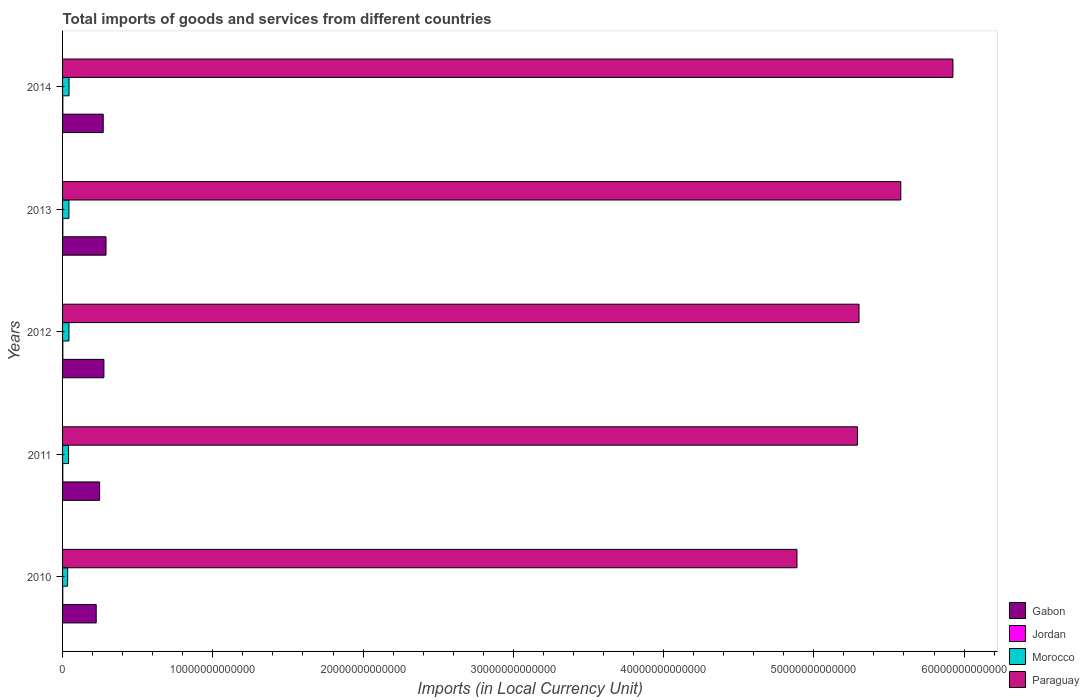How many different coloured bars are there?
Provide a short and direct response. 4. How many groups of bars are there?
Provide a short and direct response. 5. Are the number of bars on each tick of the Y-axis equal?
Offer a terse response. Yes. How many bars are there on the 4th tick from the top?
Keep it short and to the point. 4. In how many cases, is the number of bars for a given year not equal to the number of legend labels?
Offer a terse response. 0. What is the Amount of goods and services imports in Gabon in 2013?
Keep it short and to the point. 2.89e+12. Across all years, what is the maximum Amount of goods and services imports in Gabon?
Offer a very short reply. 2.89e+12. Across all years, what is the minimum Amount of goods and services imports in Jordan?
Your answer should be compact. 1.30e+1. In which year was the Amount of goods and services imports in Paraguay minimum?
Your response must be concise. 2010. What is the total Amount of goods and services imports in Jordan in the graph?
Your answer should be compact. 7.92e+1. What is the difference between the Amount of goods and services imports in Jordan in 2012 and that in 2014?
Keep it short and to the point. -1.29e+09. What is the difference between the Amount of goods and services imports in Paraguay in 2010 and the Amount of goods and services imports in Gabon in 2011?
Offer a terse response. 4.64e+13. What is the average Amount of goods and services imports in Paraguay per year?
Make the answer very short. 5.40e+13. In the year 2012, what is the difference between the Amount of goods and services imports in Morocco and Amount of goods and services imports in Jordan?
Provide a succinct answer. 4.09e+11. In how many years, is the Amount of goods and services imports in Gabon greater than 38000000000000 LCU?
Provide a short and direct response. 0. What is the ratio of the Amount of goods and services imports in Morocco in 2010 to that in 2013?
Offer a terse response. 0.8. What is the difference between the highest and the second highest Amount of goods and services imports in Jordan?
Provide a short and direct response. 4.42e+08. What is the difference between the highest and the lowest Amount of goods and services imports in Paraguay?
Make the answer very short. 1.04e+13. Is the sum of the Amount of goods and services imports in Paraguay in 2011 and 2013 greater than the maximum Amount of goods and services imports in Jordan across all years?
Offer a terse response. Yes. Is it the case that in every year, the sum of the Amount of goods and services imports in Morocco and Amount of goods and services imports in Gabon is greater than the sum of Amount of goods and services imports in Jordan and Amount of goods and services imports in Paraguay?
Keep it short and to the point. Yes. What does the 4th bar from the top in 2010 represents?
Offer a very short reply. Gabon. What does the 4th bar from the bottom in 2012 represents?
Provide a short and direct response. Paraguay. How many bars are there?
Your answer should be very brief. 20. Are all the bars in the graph horizontal?
Your response must be concise. Yes. How many years are there in the graph?
Provide a succinct answer. 5. What is the difference between two consecutive major ticks on the X-axis?
Your answer should be very brief. 1.00e+13. Are the values on the major ticks of X-axis written in scientific E-notation?
Make the answer very short. No. Does the graph contain grids?
Your answer should be compact. No. Where does the legend appear in the graph?
Offer a terse response. Bottom right. How many legend labels are there?
Provide a short and direct response. 4. What is the title of the graph?
Your response must be concise. Total imports of goods and services from different countries. Does "Hungary" appear as one of the legend labels in the graph?
Provide a succinct answer. No. What is the label or title of the X-axis?
Offer a very short reply. Imports (in Local Currency Unit). What is the label or title of the Y-axis?
Your answer should be compact. Years. What is the Imports (in Local Currency Unit) of Gabon in 2010?
Your response must be concise. 2.24e+12. What is the Imports (in Local Currency Unit) in Jordan in 2010?
Your answer should be very brief. 1.30e+1. What is the Imports (in Local Currency Unit) in Morocco in 2010?
Your response must be concise. 3.38e+11. What is the Imports (in Local Currency Unit) in Paraguay in 2010?
Your answer should be compact. 4.89e+13. What is the Imports (in Local Currency Unit) in Gabon in 2011?
Give a very brief answer. 2.47e+12. What is the Imports (in Local Currency Unit) of Jordan in 2011?
Your response must be concise. 1.51e+1. What is the Imports (in Local Currency Unit) of Morocco in 2011?
Provide a succinct answer. 4.00e+11. What is the Imports (in Local Currency Unit) in Paraguay in 2011?
Ensure brevity in your answer.  5.29e+13. What is the Imports (in Local Currency Unit) of Gabon in 2012?
Offer a terse response. 2.75e+12. What is the Imports (in Local Currency Unit) of Jordan in 2012?
Offer a terse response. 1.63e+1. What is the Imports (in Local Currency Unit) in Morocco in 2012?
Make the answer very short. 4.26e+11. What is the Imports (in Local Currency Unit) in Paraguay in 2012?
Provide a succinct answer. 5.30e+13. What is the Imports (in Local Currency Unit) in Gabon in 2013?
Offer a terse response. 2.89e+12. What is the Imports (in Local Currency Unit) of Jordan in 2013?
Your answer should be very brief. 1.72e+1. What is the Imports (in Local Currency Unit) in Morocco in 2013?
Offer a terse response. 4.24e+11. What is the Imports (in Local Currency Unit) in Paraguay in 2013?
Your response must be concise. 5.58e+13. What is the Imports (in Local Currency Unit) of Gabon in 2014?
Keep it short and to the point. 2.71e+12. What is the Imports (in Local Currency Unit) of Jordan in 2014?
Your answer should be compact. 1.76e+1. What is the Imports (in Local Currency Unit) in Morocco in 2014?
Offer a very short reply. 4.31e+11. What is the Imports (in Local Currency Unit) in Paraguay in 2014?
Your response must be concise. 5.93e+13. Across all years, what is the maximum Imports (in Local Currency Unit) of Gabon?
Your answer should be compact. 2.89e+12. Across all years, what is the maximum Imports (in Local Currency Unit) in Jordan?
Make the answer very short. 1.76e+1. Across all years, what is the maximum Imports (in Local Currency Unit) of Morocco?
Your answer should be very brief. 4.31e+11. Across all years, what is the maximum Imports (in Local Currency Unit) in Paraguay?
Offer a terse response. 5.93e+13. Across all years, what is the minimum Imports (in Local Currency Unit) in Gabon?
Make the answer very short. 2.24e+12. Across all years, what is the minimum Imports (in Local Currency Unit) in Jordan?
Give a very brief answer. 1.30e+1. Across all years, what is the minimum Imports (in Local Currency Unit) of Morocco?
Your answer should be compact. 3.38e+11. Across all years, what is the minimum Imports (in Local Currency Unit) in Paraguay?
Offer a terse response. 4.89e+13. What is the total Imports (in Local Currency Unit) of Gabon in the graph?
Provide a succinct answer. 1.31e+13. What is the total Imports (in Local Currency Unit) of Jordan in the graph?
Make the answer very short. 7.92e+1. What is the total Imports (in Local Currency Unit) of Morocco in the graph?
Your answer should be compact. 2.02e+12. What is the total Imports (in Local Currency Unit) of Paraguay in the graph?
Provide a short and direct response. 2.70e+14. What is the difference between the Imports (in Local Currency Unit) of Gabon in 2010 and that in 2011?
Provide a short and direct response. -2.28e+11. What is the difference between the Imports (in Local Currency Unit) of Jordan in 2010 and that in 2011?
Your answer should be compact. -2.17e+09. What is the difference between the Imports (in Local Currency Unit) in Morocco in 2010 and that in 2011?
Offer a terse response. -6.21e+1. What is the difference between the Imports (in Local Currency Unit) of Paraguay in 2010 and that in 2011?
Give a very brief answer. -4.03e+12. What is the difference between the Imports (in Local Currency Unit) in Gabon in 2010 and that in 2012?
Provide a short and direct response. -5.12e+11. What is the difference between the Imports (in Local Currency Unit) of Jordan in 2010 and that in 2012?
Your response must be concise. -3.36e+09. What is the difference between the Imports (in Local Currency Unit) of Morocco in 2010 and that in 2012?
Make the answer very short. -8.81e+1. What is the difference between the Imports (in Local Currency Unit) of Paraguay in 2010 and that in 2012?
Your answer should be very brief. -4.13e+12. What is the difference between the Imports (in Local Currency Unit) of Gabon in 2010 and that in 2013?
Ensure brevity in your answer.  -6.52e+11. What is the difference between the Imports (in Local Currency Unit) of Jordan in 2010 and that in 2013?
Provide a succinct answer. -4.21e+09. What is the difference between the Imports (in Local Currency Unit) of Morocco in 2010 and that in 2013?
Keep it short and to the point. -8.67e+1. What is the difference between the Imports (in Local Currency Unit) in Paraguay in 2010 and that in 2013?
Offer a very short reply. -6.91e+12. What is the difference between the Imports (in Local Currency Unit) of Gabon in 2010 and that in 2014?
Your answer should be very brief. -4.67e+11. What is the difference between the Imports (in Local Currency Unit) in Jordan in 2010 and that in 2014?
Offer a very short reply. -4.65e+09. What is the difference between the Imports (in Local Currency Unit) of Morocco in 2010 and that in 2014?
Give a very brief answer. -9.36e+1. What is the difference between the Imports (in Local Currency Unit) of Paraguay in 2010 and that in 2014?
Offer a very short reply. -1.04e+13. What is the difference between the Imports (in Local Currency Unit) in Gabon in 2011 and that in 2012?
Provide a short and direct response. -2.84e+11. What is the difference between the Imports (in Local Currency Unit) of Jordan in 2011 and that in 2012?
Offer a very short reply. -1.19e+09. What is the difference between the Imports (in Local Currency Unit) in Morocco in 2011 and that in 2012?
Your answer should be very brief. -2.60e+1. What is the difference between the Imports (in Local Currency Unit) of Paraguay in 2011 and that in 2012?
Provide a succinct answer. -1.05e+11. What is the difference between the Imports (in Local Currency Unit) of Gabon in 2011 and that in 2013?
Your answer should be compact. -4.24e+11. What is the difference between the Imports (in Local Currency Unit) of Jordan in 2011 and that in 2013?
Offer a terse response. -2.04e+09. What is the difference between the Imports (in Local Currency Unit) of Morocco in 2011 and that in 2013?
Your response must be concise. -2.46e+1. What is the difference between the Imports (in Local Currency Unit) of Paraguay in 2011 and that in 2013?
Your answer should be very brief. -2.89e+12. What is the difference between the Imports (in Local Currency Unit) in Gabon in 2011 and that in 2014?
Your response must be concise. -2.39e+11. What is the difference between the Imports (in Local Currency Unit) in Jordan in 2011 and that in 2014?
Offer a very short reply. -2.48e+09. What is the difference between the Imports (in Local Currency Unit) in Morocco in 2011 and that in 2014?
Make the answer very short. -3.15e+1. What is the difference between the Imports (in Local Currency Unit) of Paraguay in 2011 and that in 2014?
Offer a very short reply. -6.36e+12. What is the difference between the Imports (in Local Currency Unit) of Gabon in 2012 and that in 2013?
Make the answer very short. -1.40e+11. What is the difference between the Imports (in Local Currency Unit) of Jordan in 2012 and that in 2013?
Keep it short and to the point. -8.50e+08. What is the difference between the Imports (in Local Currency Unit) of Morocco in 2012 and that in 2013?
Provide a succinct answer. 1.39e+09. What is the difference between the Imports (in Local Currency Unit) in Paraguay in 2012 and that in 2013?
Give a very brief answer. -2.78e+12. What is the difference between the Imports (in Local Currency Unit) of Gabon in 2012 and that in 2014?
Make the answer very short. 4.55e+1. What is the difference between the Imports (in Local Currency Unit) in Jordan in 2012 and that in 2014?
Your answer should be compact. -1.29e+09. What is the difference between the Imports (in Local Currency Unit) of Morocco in 2012 and that in 2014?
Make the answer very short. -5.54e+09. What is the difference between the Imports (in Local Currency Unit) of Paraguay in 2012 and that in 2014?
Ensure brevity in your answer.  -6.25e+12. What is the difference between the Imports (in Local Currency Unit) in Gabon in 2013 and that in 2014?
Offer a very short reply. 1.85e+11. What is the difference between the Imports (in Local Currency Unit) in Jordan in 2013 and that in 2014?
Your answer should be very brief. -4.42e+08. What is the difference between the Imports (in Local Currency Unit) of Morocco in 2013 and that in 2014?
Provide a succinct answer. -6.93e+09. What is the difference between the Imports (in Local Currency Unit) of Paraguay in 2013 and that in 2014?
Ensure brevity in your answer.  -3.47e+12. What is the difference between the Imports (in Local Currency Unit) of Gabon in 2010 and the Imports (in Local Currency Unit) of Jordan in 2011?
Keep it short and to the point. 2.22e+12. What is the difference between the Imports (in Local Currency Unit) in Gabon in 2010 and the Imports (in Local Currency Unit) in Morocco in 2011?
Provide a succinct answer. 1.84e+12. What is the difference between the Imports (in Local Currency Unit) of Gabon in 2010 and the Imports (in Local Currency Unit) of Paraguay in 2011?
Ensure brevity in your answer.  -5.07e+13. What is the difference between the Imports (in Local Currency Unit) in Jordan in 2010 and the Imports (in Local Currency Unit) in Morocco in 2011?
Provide a succinct answer. -3.87e+11. What is the difference between the Imports (in Local Currency Unit) of Jordan in 2010 and the Imports (in Local Currency Unit) of Paraguay in 2011?
Offer a very short reply. -5.29e+13. What is the difference between the Imports (in Local Currency Unit) in Morocco in 2010 and the Imports (in Local Currency Unit) in Paraguay in 2011?
Give a very brief answer. -5.26e+13. What is the difference between the Imports (in Local Currency Unit) of Gabon in 2010 and the Imports (in Local Currency Unit) of Jordan in 2012?
Offer a terse response. 2.22e+12. What is the difference between the Imports (in Local Currency Unit) in Gabon in 2010 and the Imports (in Local Currency Unit) in Morocco in 2012?
Your answer should be compact. 1.81e+12. What is the difference between the Imports (in Local Currency Unit) of Gabon in 2010 and the Imports (in Local Currency Unit) of Paraguay in 2012?
Your response must be concise. -5.08e+13. What is the difference between the Imports (in Local Currency Unit) in Jordan in 2010 and the Imports (in Local Currency Unit) in Morocco in 2012?
Make the answer very short. -4.13e+11. What is the difference between the Imports (in Local Currency Unit) of Jordan in 2010 and the Imports (in Local Currency Unit) of Paraguay in 2012?
Your answer should be very brief. -5.30e+13. What is the difference between the Imports (in Local Currency Unit) in Morocco in 2010 and the Imports (in Local Currency Unit) in Paraguay in 2012?
Provide a succinct answer. -5.27e+13. What is the difference between the Imports (in Local Currency Unit) in Gabon in 2010 and the Imports (in Local Currency Unit) in Jordan in 2013?
Your response must be concise. 2.22e+12. What is the difference between the Imports (in Local Currency Unit) of Gabon in 2010 and the Imports (in Local Currency Unit) of Morocco in 2013?
Your response must be concise. 1.82e+12. What is the difference between the Imports (in Local Currency Unit) of Gabon in 2010 and the Imports (in Local Currency Unit) of Paraguay in 2013?
Offer a very short reply. -5.35e+13. What is the difference between the Imports (in Local Currency Unit) in Jordan in 2010 and the Imports (in Local Currency Unit) in Morocco in 2013?
Provide a short and direct response. -4.11e+11. What is the difference between the Imports (in Local Currency Unit) in Jordan in 2010 and the Imports (in Local Currency Unit) in Paraguay in 2013?
Offer a terse response. -5.58e+13. What is the difference between the Imports (in Local Currency Unit) of Morocco in 2010 and the Imports (in Local Currency Unit) of Paraguay in 2013?
Your answer should be very brief. -5.55e+13. What is the difference between the Imports (in Local Currency Unit) of Gabon in 2010 and the Imports (in Local Currency Unit) of Jordan in 2014?
Ensure brevity in your answer.  2.22e+12. What is the difference between the Imports (in Local Currency Unit) in Gabon in 2010 and the Imports (in Local Currency Unit) in Morocco in 2014?
Your answer should be compact. 1.81e+12. What is the difference between the Imports (in Local Currency Unit) in Gabon in 2010 and the Imports (in Local Currency Unit) in Paraguay in 2014?
Make the answer very short. -5.70e+13. What is the difference between the Imports (in Local Currency Unit) of Jordan in 2010 and the Imports (in Local Currency Unit) of Morocco in 2014?
Ensure brevity in your answer.  -4.18e+11. What is the difference between the Imports (in Local Currency Unit) in Jordan in 2010 and the Imports (in Local Currency Unit) in Paraguay in 2014?
Offer a very short reply. -5.92e+13. What is the difference between the Imports (in Local Currency Unit) in Morocco in 2010 and the Imports (in Local Currency Unit) in Paraguay in 2014?
Give a very brief answer. -5.89e+13. What is the difference between the Imports (in Local Currency Unit) of Gabon in 2011 and the Imports (in Local Currency Unit) of Jordan in 2012?
Provide a succinct answer. 2.45e+12. What is the difference between the Imports (in Local Currency Unit) in Gabon in 2011 and the Imports (in Local Currency Unit) in Morocco in 2012?
Your answer should be compact. 2.04e+12. What is the difference between the Imports (in Local Currency Unit) in Gabon in 2011 and the Imports (in Local Currency Unit) in Paraguay in 2012?
Keep it short and to the point. -5.05e+13. What is the difference between the Imports (in Local Currency Unit) in Jordan in 2011 and the Imports (in Local Currency Unit) in Morocco in 2012?
Keep it short and to the point. -4.10e+11. What is the difference between the Imports (in Local Currency Unit) in Jordan in 2011 and the Imports (in Local Currency Unit) in Paraguay in 2012?
Your answer should be very brief. -5.30e+13. What is the difference between the Imports (in Local Currency Unit) of Morocco in 2011 and the Imports (in Local Currency Unit) of Paraguay in 2012?
Offer a very short reply. -5.26e+13. What is the difference between the Imports (in Local Currency Unit) in Gabon in 2011 and the Imports (in Local Currency Unit) in Jordan in 2013?
Offer a terse response. 2.45e+12. What is the difference between the Imports (in Local Currency Unit) of Gabon in 2011 and the Imports (in Local Currency Unit) of Morocco in 2013?
Your answer should be compact. 2.04e+12. What is the difference between the Imports (in Local Currency Unit) of Gabon in 2011 and the Imports (in Local Currency Unit) of Paraguay in 2013?
Offer a terse response. -5.33e+13. What is the difference between the Imports (in Local Currency Unit) of Jordan in 2011 and the Imports (in Local Currency Unit) of Morocco in 2013?
Your answer should be very brief. -4.09e+11. What is the difference between the Imports (in Local Currency Unit) of Jordan in 2011 and the Imports (in Local Currency Unit) of Paraguay in 2013?
Your answer should be compact. -5.58e+13. What is the difference between the Imports (in Local Currency Unit) of Morocco in 2011 and the Imports (in Local Currency Unit) of Paraguay in 2013?
Provide a short and direct response. -5.54e+13. What is the difference between the Imports (in Local Currency Unit) of Gabon in 2011 and the Imports (in Local Currency Unit) of Jordan in 2014?
Give a very brief answer. 2.45e+12. What is the difference between the Imports (in Local Currency Unit) in Gabon in 2011 and the Imports (in Local Currency Unit) in Morocco in 2014?
Provide a succinct answer. 2.04e+12. What is the difference between the Imports (in Local Currency Unit) in Gabon in 2011 and the Imports (in Local Currency Unit) in Paraguay in 2014?
Ensure brevity in your answer.  -5.68e+13. What is the difference between the Imports (in Local Currency Unit) in Jordan in 2011 and the Imports (in Local Currency Unit) in Morocco in 2014?
Provide a succinct answer. -4.16e+11. What is the difference between the Imports (in Local Currency Unit) in Jordan in 2011 and the Imports (in Local Currency Unit) in Paraguay in 2014?
Make the answer very short. -5.92e+13. What is the difference between the Imports (in Local Currency Unit) in Morocco in 2011 and the Imports (in Local Currency Unit) in Paraguay in 2014?
Give a very brief answer. -5.89e+13. What is the difference between the Imports (in Local Currency Unit) in Gabon in 2012 and the Imports (in Local Currency Unit) in Jordan in 2013?
Offer a terse response. 2.73e+12. What is the difference between the Imports (in Local Currency Unit) of Gabon in 2012 and the Imports (in Local Currency Unit) of Morocco in 2013?
Provide a short and direct response. 2.33e+12. What is the difference between the Imports (in Local Currency Unit) in Gabon in 2012 and the Imports (in Local Currency Unit) in Paraguay in 2013?
Your answer should be compact. -5.30e+13. What is the difference between the Imports (in Local Currency Unit) of Jordan in 2012 and the Imports (in Local Currency Unit) of Morocco in 2013?
Offer a terse response. -4.08e+11. What is the difference between the Imports (in Local Currency Unit) in Jordan in 2012 and the Imports (in Local Currency Unit) in Paraguay in 2013?
Ensure brevity in your answer.  -5.58e+13. What is the difference between the Imports (in Local Currency Unit) in Morocco in 2012 and the Imports (in Local Currency Unit) in Paraguay in 2013?
Give a very brief answer. -5.54e+13. What is the difference between the Imports (in Local Currency Unit) in Gabon in 2012 and the Imports (in Local Currency Unit) in Jordan in 2014?
Offer a terse response. 2.73e+12. What is the difference between the Imports (in Local Currency Unit) of Gabon in 2012 and the Imports (in Local Currency Unit) of Morocco in 2014?
Give a very brief answer. 2.32e+12. What is the difference between the Imports (in Local Currency Unit) in Gabon in 2012 and the Imports (in Local Currency Unit) in Paraguay in 2014?
Offer a terse response. -5.65e+13. What is the difference between the Imports (in Local Currency Unit) of Jordan in 2012 and the Imports (in Local Currency Unit) of Morocco in 2014?
Keep it short and to the point. -4.15e+11. What is the difference between the Imports (in Local Currency Unit) in Jordan in 2012 and the Imports (in Local Currency Unit) in Paraguay in 2014?
Offer a very short reply. -5.92e+13. What is the difference between the Imports (in Local Currency Unit) in Morocco in 2012 and the Imports (in Local Currency Unit) in Paraguay in 2014?
Provide a short and direct response. -5.88e+13. What is the difference between the Imports (in Local Currency Unit) in Gabon in 2013 and the Imports (in Local Currency Unit) in Jordan in 2014?
Offer a very short reply. 2.87e+12. What is the difference between the Imports (in Local Currency Unit) of Gabon in 2013 and the Imports (in Local Currency Unit) of Morocco in 2014?
Your answer should be compact. 2.46e+12. What is the difference between the Imports (in Local Currency Unit) in Gabon in 2013 and the Imports (in Local Currency Unit) in Paraguay in 2014?
Give a very brief answer. -5.64e+13. What is the difference between the Imports (in Local Currency Unit) of Jordan in 2013 and the Imports (in Local Currency Unit) of Morocco in 2014?
Ensure brevity in your answer.  -4.14e+11. What is the difference between the Imports (in Local Currency Unit) in Jordan in 2013 and the Imports (in Local Currency Unit) in Paraguay in 2014?
Your response must be concise. -5.92e+13. What is the difference between the Imports (in Local Currency Unit) in Morocco in 2013 and the Imports (in Local Currency Unit) in Paraguay in 2014?
Offer a very short reply. -5.88e+13. What is the average Imports (in Local Currency Unit) in Gabon per year?
Your answer should be compact. 2.61e+12. What is the average Imports (in Local Currency Unit) of Jordan per year?
Provide a succinct answer. 1.58e+1. What is the average Imports (in Local Currency Unit) of Morocco per year?
Ensure brevity in your answer.  4.04e+11. What is the average Imports (in Local Currency Unit) in Paraguay per year?
Your answer should be very brief. 5.40e+13. In the year 2010, what is the difference between the Imports (in Local Currency Unit) of Gabon and Imports (in Local Currency Unit) of Jordan?
Give a very brief answer. 2.23e+12. In the year 2010, what is the difference between the Imports (in Local Currency Unit) of Gabon and Imports (in Local Currency Unit) of Morocco?
Offer a terse response. 1.90e+12. In the year 2010, what is the difference between the Imports (in Local Currency Unit) in Gabon and Imports (in Local Currency Unit) in Paraguay?
Your answer should be very brief. -4.66e+13. In the year 2010, what is the difference between the Imports (in Local Currency Unit) of Jordan and Imports (in Local Currency Unit) of Morocco?
Your response must be concise. -3.25e+11. In the year 2010, what is the difference between the Imports (in Local Currency Unit) of Jordan and Imports (in Local Currency Unit) of Paraguay?
Keep it short and to the point. -4.89e+13. In the year 2010, what is the difference between the Imports (in Local Currency Unit) in Morocco and Imports (in Local Currency Unit) in Paraguay?
Offer a very short reply. -4.85e+13. In the year 2011, what is the difference between the Imports (in Local Currency Unit) in Gabon and Imports (in Local Currency Unit) in Jordan?
Your answer should be very brief. 2.45e+12. In the year 2011, what is the difference between the Imports (in Local Currency Unit) in Gabon and Imports (in Local Currency Unit) in Morocco?
Offer a terse response. 2.07e+12. In the year 2011, what is the difference between the Imports (in Local Currency Unit) of Gabon and Imports (in Local Currency Unit) of Paraguay?
Offer a very short reply. -5.04e+13. In the year 2011, what is the difference between the Imports (in Local Currency Unit) of Jordan and Imports (in Local Currency Unit) of Morocco?
Provide a short and direct response. -3.84e+11. In the year 2011, what is the difference between the Imports (in Local Currency Unit) of Jordan and Imports (in Local Currency Unit) of Paraguay?
Keep it short and to the point. -5.29e+13. In the year 2011, what is the difference between the Imports (in Local Currency Unit) in Morocco and Imports (in Local Currency Unit) in Paraguay?
Keep it short and to the point. -5.25e+13. In the year 2012, what is the difference between the Imports (in Local Currency Unit) in Gabon and Imports (in Local Currency Unit) in Jordan?
Offer a very short reply. 2.74e+12. In the year 2012, what is the difference between the Imports (in Local Currency Unit) in Gabon and Imports (in Local Currency Unit) in Morocco?
Provide a short and direct response. 2.33e+12. In the year 2012, what is the difference between the Imports (in Local Currency Unit) of Gabon and Imports (in Local Currency Unit) of Paraguay?
Keep it short and to the point. -5.03e+13. In the year 2012, what is the difference between the Imports (in Local Currency Unit) in Jordan and Imports (in Local Currency Unit) in Morocco?
Make the answer very short. -4.09e+11. In the year 2012, what is the difference between the Imports (in Local Currency Unit) of Jordan and Imports (in Local Currency Unit) of Paraguay?
Your answer should be compact. -5.30e+13. In the year 2012, what is the difference between the Imports (in Local Currency Unit) of Morocco and Imports (in Local Currency Unit) of Paraguay?
Ensure brevity in your answer.  -5.26e+13. In the year 2013, what is the difference between the Imports (in Local Currency Unit) of Gabon and Imports (in Local Currency Unit) of Jordan?
Offer a terse response. 2.87e+12. In the year 2013, what is the difference between the Imports (in Local Currency Unit) of Gabon and Imports (in Local Currency Unit) of Morocco?
Your answer should be compact. 2.47e+12. In the year 2013, what is the difference between the Imports (in Local Currency Unit) of Gabon and Imports (in Local Currency Unit) of Paraguay?
Give a very brief answer. -5.29e+13. In the year 2013, what is the difference between the Imports (in Local Currency Unit) of Jordan and Imports (in Local Currency Unit) of Morocco?
Keep it short and to the point. -4.07e+11. In the year 2013, what is the difference between the Imports (in Local Currency Unit) in Jordan and Imports (in Local Currency Unit) in Paraguay?
Ensure brevity in your answer.  -5.58e+13. In the year 2013, what is the difference between the Imports (in Local Currency Unit) of Morocco and Imports (in Local Currency Unit) of Paraguay?
Provide a short and direct response. -5.54e+13. In the year 2014, what is the difference between the Imports (in Local Currency Unit) in Gabon and Imports (in Local Currency Unit) in Jordan?
Your response must be concise. 2.69e+12. In the year 2014, what is the difference between the Imports (in Local Currency Unit) in Gabon and Imports (in Local Currency Unit) in Morocco?
Your response must be concise. 2.28e+12. In the year 2014, what is the difference between the Imports (in Local Currency Unit) in Gabon and Imports (in Local Currency Unit) in Paraguay?
Offer a very short reply. -5.66e+13. In the year 2014, what is the difference between the Imports (in Local Currency Unit) in Jordan and Imports (in Local Currency Unit) in Morocco?
Ensure brevity in your answer.  -4.14e+11. In the year 2014, what is the difference between the Imports (in Local Currency Unit) of Jordan and Imports (in Local Currency Unit) of Paraguay?
Your answer should be compact. -5.92e+13. In the year 2014, what is the difference between the Imports (in Local Currency Unit) of Morocco and Imports (in Local Currency Unit) of Paraguay?
Your response must be concise. -5.88e+13. What is the ratio of the Imports (in Local Currency Unit) of Gabon in 2010 to that in 2011?
Provide a succinct answer. 0.91. What is the ratio of the Imports (in Local Currency Unit) in Jordan in 2010 to that in 2011?
Offer a terse response. 0.86. What is the ratio of the Imports (in Local Currency Unit) in Morocco in 2010 to that in 2011?
Offer a terse response. 0.84. What is the ratio of the Imports (in Local Currency Unit) of Paraguay in 2010 to that in 2011?
Keep it short and to the point. 0.92. What is the ratio of the Imports (in Local Currency Unit) in Gabon in 2010 to that in 2012?
Provide a short and direct response. 0.81. What is the ratio of the Imports (in Local Currency Unit) in Jordan in 2010 to that in 2012?
Ensure brevity in your answer.  0.79. What is the ratio of the Imports (in Local Currency Unit) of Morocco in 2010 to that in 2012?
Your answer should be very brief. 0.79. What is the ratio of the Imports (in Local Currency Unit) in Paraguay in 2010 to that in 2012?
Give a very brief answer. 0.92. What is the ratio of the Imports (in Local Currency Unit) of Gabon in 2010 to that in 2013?
Ensure brevity in your answer.  0.77. What is the ratio of the Imports (in Local Currency Unit) of Jordan in 2010 to that in 2013?
Your answer should be very brief. 0.75. What is the ratio of the Imports (in Local Currency Unit) of Morocco in 2010 to that in 2013?
Ensure brevity in your answer.  0.8. What is the ratio of the Imports (in Local Currency Unit) in Paraguay in 2010 to that in 2013?
Provide a succinct answer. 0.88. What is the ratio of the Imports (in Local Currency Unit) of Gabon in 2010 to that in 2014?
Keep it short and to the point. 0.83. What is the ratio of the Imports (in Local Currency Unit) in Jordan in 2010 to that in 2014?
Make the answer very short. 0.74. What is the ratio of the Imports (in Local Currency Unit) of Morocco in 2010 to that in 2014?
Provide a short and direct response. 0.78. What is the ratio of the Imports (in Local Currency Unit) in Paraguay in 2010 to that in 2014?
Offer a terse response. 0.82. What is the ratio of the Imports (in Local Currency Unit) in Gabon in 2011 to that in 2012?
Offer a terse response. 0.9. What is the ratio of the Imports (in Local Currency Unit) of Jordan in 2011 to that in 2012?
Offer a terse response. 0.93. What is the ratio of the Imports (in Local Currency Unit) in Morocco in 2011 to that in 2012?
Provide a succinct answer. 0.94. What is the ratio of the Imports (in Local Currency Unit) of Gabon in 2011 to that in 2013?
Your answer should be very brief. 0.85. What is the ratio of the Imports (in Local Currency Unit) in Jordan in 2011 to that in 2013?
Give a very brief answer. 0.88. What is the ratio of the Imports (in Local Currency Unit) of Morocco in 2011 to that in 2013?
Keep it short and to the point. 0.94. What is the ratio of the Imports (in Local Currency Unit) in Paraguay in 2011 to that in 2013?
Offer a very short reply. 0.95. What is the ratio of the Imports (in Local Currency Unit) of Gabon in 2011 to that in 2014?
Make the answer very short. 0.91. What is the ratio of the Imports (in Local Currency Unit) of Jordan in 2011 to that in 2014?
Give a very brief answer. 0.86. What is the ratio of the Imports (in Local Currency Unit) of Morocco in 2011 to that in 2014?
Make the answer very short. 0.93. What is the ratio of the Imports (in Local Currency Unit) of Paraguay in 2011 to that in 2014?
Your answer should be very brief. 0.89. What is the ratio of the Imports (in Local Currency Unit) of Gabon in 2012 to that in 2013?
Provide a succinct answer. 0.95. What is the ratio of the Imports (in Local Currency Unit) of Jordan in 2012 to that in 2013?
Offer a very short reply. 0.95. What is the ratio of the Imports (in Local Currency Unit) of Paraguay in 2012 to that in 2013?
Make the answer very short. 0.95. What is the ratio of the Imports (in Local Currency Unit) of Gabon in 2012 to that in 2014?
Your answer should be very brief. 1.02. What is the ratio of the Imports (in Local Currency Unit) in Jordan in 2012 to that in 2014?
Offer a terse response. 0.93. What is the ratio of the Imports (in Local Currency Unit) in Morocco in 2012 to that in 2014?
Give a very brief answer. 0.99. What is the ratio of the Imports (in Local Currency Unit) of Paraguay in 2012 to that in 2014?
Ensure brevity in your answer.  0.89. What is the ratio of the Imports (in Local Currency Unit) in Gabon in 2013 to that in 2014?
Your response must be concise. 1.07. What is the ratio of the Imports (in Local Currency Unit) in Jordan in 2013 to that in 2014?
Provide a short and direct response. 0.97. What is the ratio of the Imports (in Local Currency Unit) in Morocco in 2013 to that in 2014?
Give a very brief answer. 0.98. What is the ratio of the Imports (in Local Currency Unit) of Paraguay in 2013 to that in 2014?
Make the answer very short. 0.94. What is the difference between the highest and the second highest Imports (in Local Currency Unit) in Gabon?
Your answer should be very brief. 1.40e+11. What is the difference between the highest and the second highest Imports (in Local Currency Unit) of Jordan?
Ensure brevity in your answer.  4.42e+08. What is the difference between the highest and the second highest Imports (in Local Currency Unit) in Morocco?
Your response must be concise. 5.54e+09. What is the difference between the highest and the second highest Imports (in Local Currency Unit) in Paraguay?
Your answer should be compact. 3.47e+12. What is the difference between the highest and the lowest Imports (in Local Currency Unit) in Gabon?
Your response must be concise. 6.52e+11. What is the difference between the highest and the lowest Imports (in Local Currency Unit) of Jordan?
Your response must be concise. 4.65e+09. What is the difference between the highest and the lowest Imports (in Local Currency Unit) of Morocco?
Provide a succinct answer. 9.36e+1. What is the difference between the highest and the lowest Imports (in Local Currency Unit) in Paraguay?
Offer a terse response. 1.04e+13. 